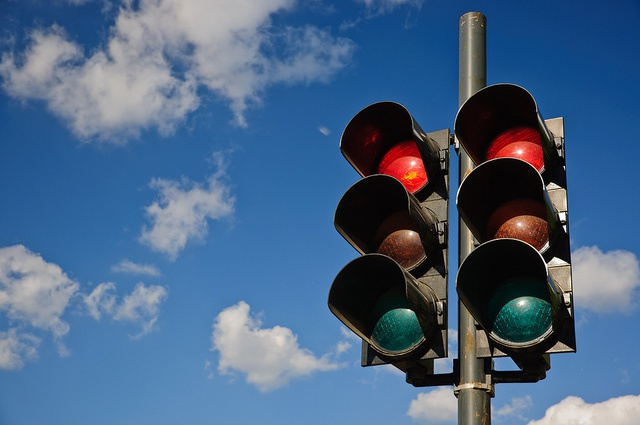Describe the objects in this image and their specific colors. I can see traffic light in navy, black, maroon, tan, and teal tones and traffic light in navy, black, gray, and maroon tones in this image. 